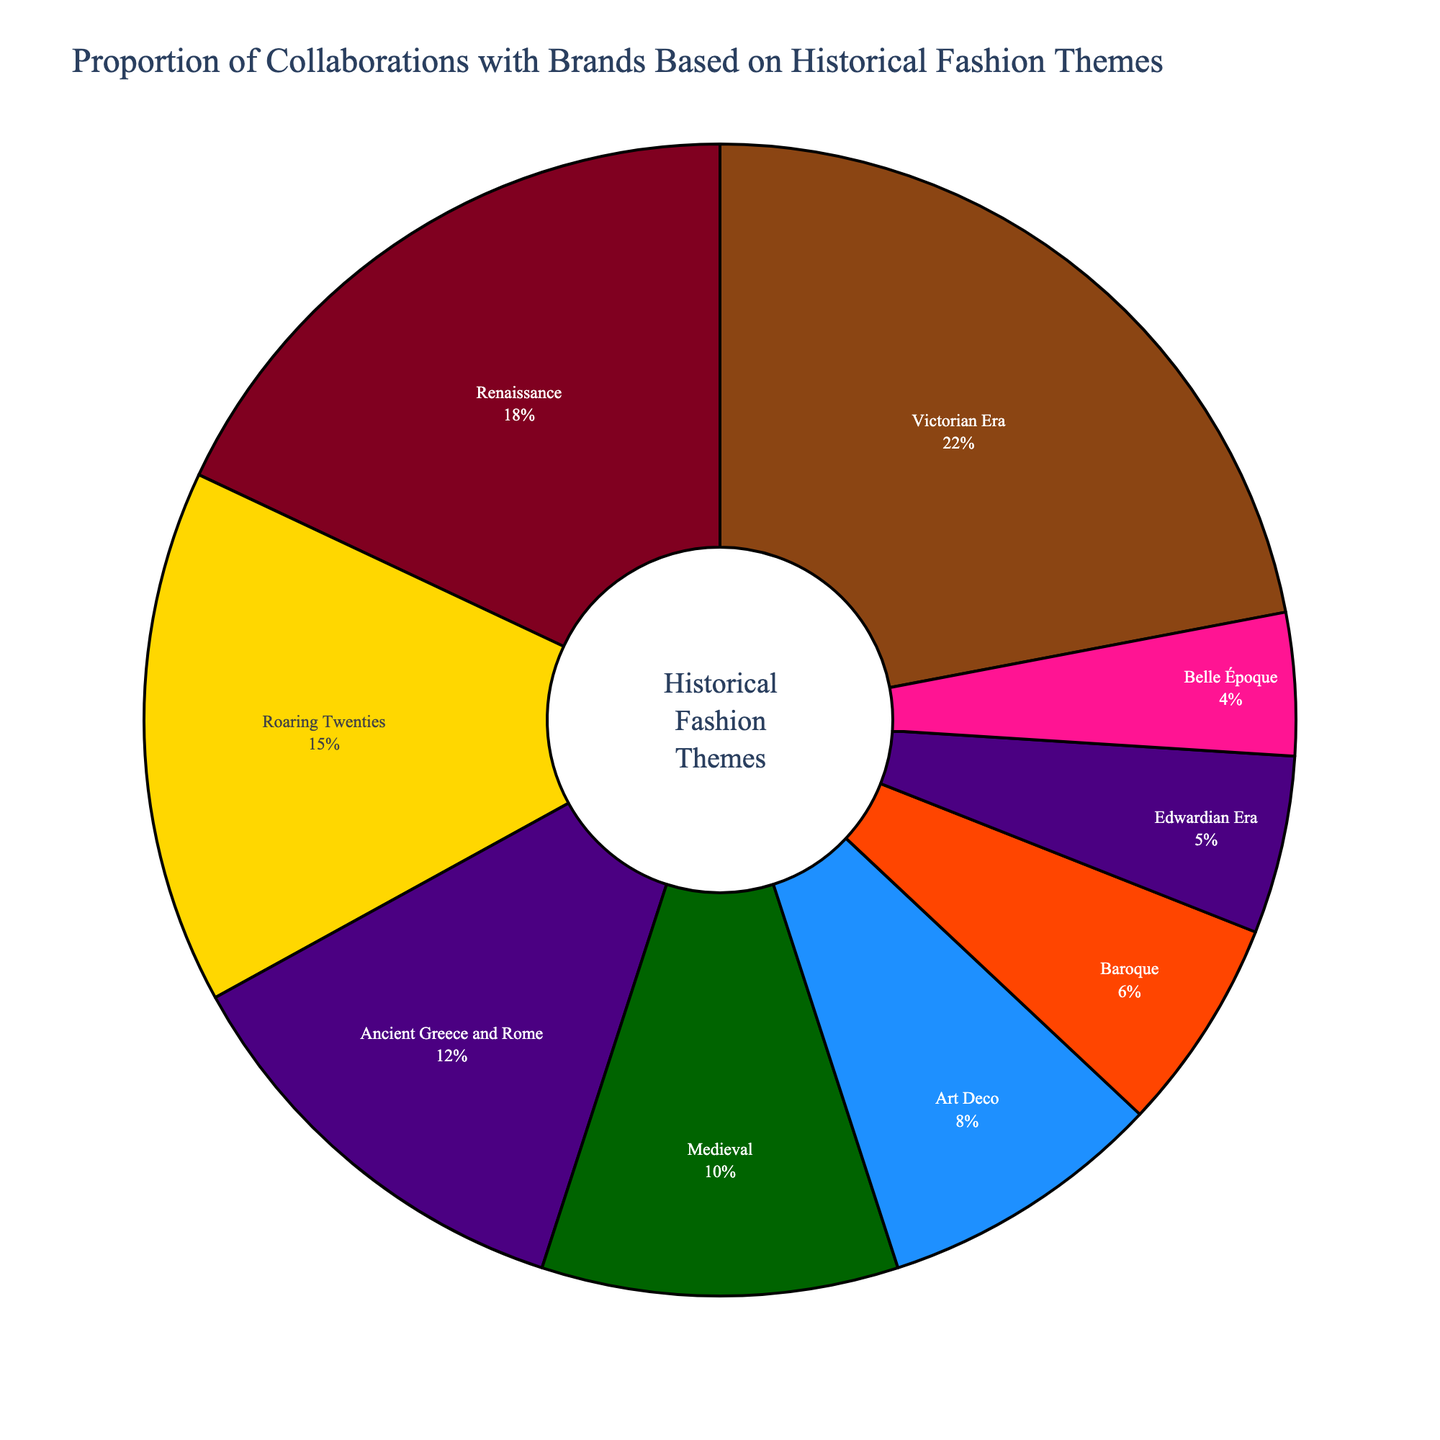What's the largest theme percentage in the pie chart? The largest theme percentage can be identified by looking at the theme with the biggest slice in the pie chart. According to the data, the Victorian Era holds the largest portion at 22%.
Answer: Victorian Era Which historical fashion theme has the smallest percentage? To find the theme with the smallest percentage, look for the smallest slice in the pie chart. The Belle Époque theme has the lowest percentage at 4%.
Answer: Belle Époque What is the combined percentage of the top three historical fashion themes? Add up the percentages of the top three themes: Victorian Era (22%), Renaissance (18%), and Roaring Twenties (15%). The combined percentage is 22 + 18 + 15 = 55%.
Answer: 55% How does the percentage of Ancient Greece and Rome compare to that of the Medieval period? Compare the slices representing Ancient Greece and Rome (12%) and the Medieval period (10%). The Ancient Greece and Rome period is 2% higher than the Medieval period.
Answer: Ancient Greece and Rome is higher Which historical theme slice is the most visually striking in terms of color contrast? The visual impact of color can be inferred by looking at the most vibrant or different color. The slice representing the Roaring Twenties with a bright golden hue stands out the most in terms of color contrast.
Answer: Roaring Twenties What is the average percentage of the bottom three themes in the chart? Calculate the average of the percentages of the bottom three themes: Baroque (6%), Edwardian Era (5%), and Belle Époque (4%). The sum is 6 + 5 + 4 = 15. The average is 15 / 3 = 5%.
Answer: 5% If you combine the percentages of the Medieval and Baroque themes, how does that total compare to the percentage of the Renaissance theme? Add the percentages of the Medieval (10%) and Baroque (6%) themes, which totals 10 + 6 = 16%. Compare this to the Renaissance theme at 18%. The combined percentage is 2% less than the Renaissance theme.
Answer: 2% less than Renaissance What proportion of the chart is represented by themes from the 20th century (i.e., Roaring Twenties and Art Deco)? Add the percentages of the 20th century themes: Roaring Twenties (15%) and Art Deco (8%). The total proportion is 15 + 8 = 23%.
Answer: 23% Is the percentage of the Renaissance theme greater than the combined percentage of both Ancient Greece and Rome and the Medieval themes? First, combine the percentages of Ancient Greece and Rome (12%) and Medieval (10%), giving 12 + 10 = 22%. The Renaissance theme percentage is 18%, which is less than 22%.
Answer: No How much more significant is the Victorian Era theme compared to the Belle Époque theme in terms of percentage? Subtract the Belle Époque percentage (4%) from the Victorian Era percentage (22%) to find the difference: 22 - 4 = 18%.
Answer: 18% 